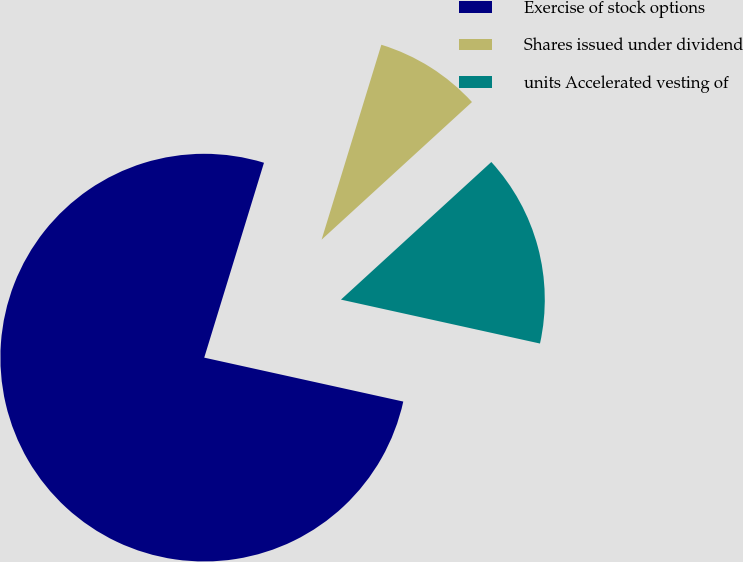Convert chart. <chart><loc_0><loc_0><loc_500><loc_500><pie_chart><fcel>Exercise of stock options<fcel>Shares issued under dividend<fcel>units Accelerated vesting of<nl><fcel>76.27%<fcel>8.47%<fcel>15.25%<nl></chart> 